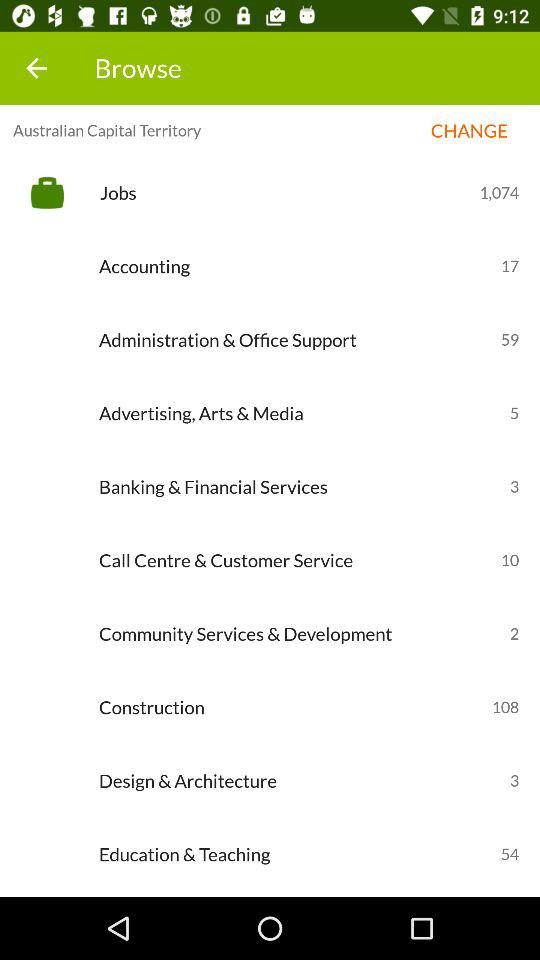How many more jobs are in the Accounting industry than in the Call Centre & Customer Service industry?
Answer the question using a single word or phrase. 7 